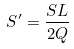<formula> <loc_0><loc_0><loc_500><loc_500>S ^ { \prime } = \frac { S L } { 2 Q }</formula> 